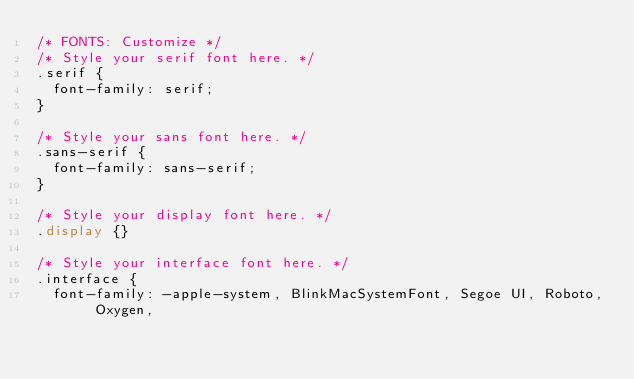<code> <loc_0><loc_0><loc_500><loc_500><_CSS_>/* FONTS: Customize */
/* Style your serif font here. */
.serif {
  font-family: serif;
}

/* Style your sans font here. */
.sans-serif {
  font-family: sans-serif;
}

/* Style your display font here. */
.display {}

/* Style your interface font here. */
.interface {
  font-family: -apple-system, BlinkMacSystemFont, Segoe UI, Roboto, Oxygen,</code> 